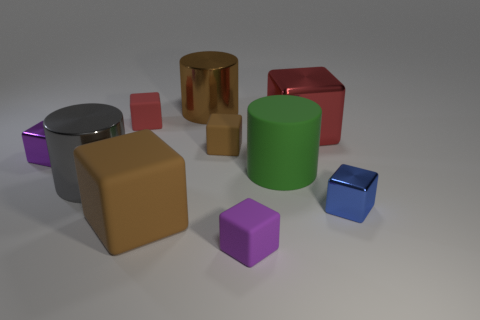Subtract all tiny blue shiny cubes. How many cubes are left? 6 Subtract all purple balls. How many red cubes are left? 2 Subtract all blue cubes. How many cubes are left? 6 Subtract all cylinders. How many objects are left? 7 Subtract 3 cylinders. How many cylinders are left? 0 Add 9 big brown metallic objects. How many big brown metallic objects are left? 10 Add 3 large green things. How many large green things exist? 4 Subtract 1 brown cylinders. How many objects are left? 9 Subtract all yellow blocks. Subtract all gray cylinders. How many blocks are left? 7 Subtract all large brown rubber objects. Subtract all big red metal cubes. How many objects are left? 8 